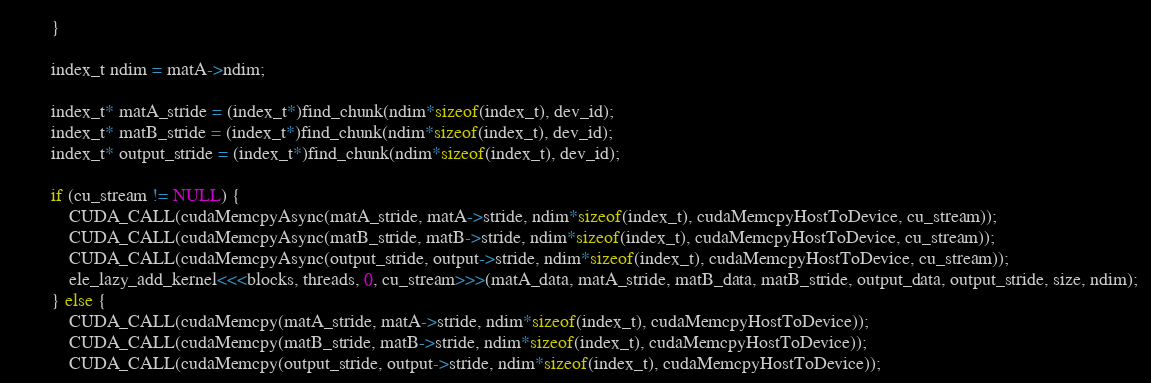<code> <loc_0><loc_0><loc_500><loc_500><_Cuda_>        }

        index_t ndim = matA->ndim;

        index_t* matA_stride = (index_t*)find_chunk(ndim*sizeof(index_t), dev_id);
        index_t* matB_stride = (index_t*)find_chunk(ndim*sizeof(index_t), dev_id);
        index_t* output_stride = (index_t*)find_chunk(ndim*sizeof(index_t), dev_id);

        if (cu_stream != NULL) {
            CUDA_CALL(cudaMemcpyAsync(matA_stride, matA->stride, ndim*sizeof(index_t), cudaMemcpyHostToDevice, cu_stream));
            CUDA_CALL(cudaMemcpyAsync(matB_stride, matB->stride, ndim*sizeof(index_t), cudaMemcpyHostToDevice, cu_stream));
            CUDA_CALL(cudaMemcpyAsync(output_stride, output->stride, ndim*sizeof(index_t), cudaMemcpyHostToDevice, cu_stream));
            ele_lazy_add_kernel<<<blocks, threads, 0, cu_stream>>>(matA_data, matA_stride, matB_data, matB_stride, output_data, output_stride, size, ndim);
        } else {
            CUDA_CALL(cudaMemcpy(matA_stride, matA->stride, ndim*sizeof(index_t), cudaMemcpyHostToDevice));
            CUDA_CALL(cudaMemcpy(matB_stride, matB->stride, ndim*sizeof(index_t), cudaMemcpyHostToDevice));
            CUDA_CALL(cudaMemcpy(output_stride, output->stride, ndim*sizeof(index_t), cudaMemcpyHostToDevice));</code> 